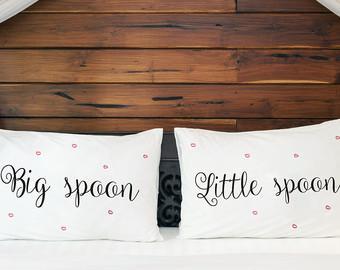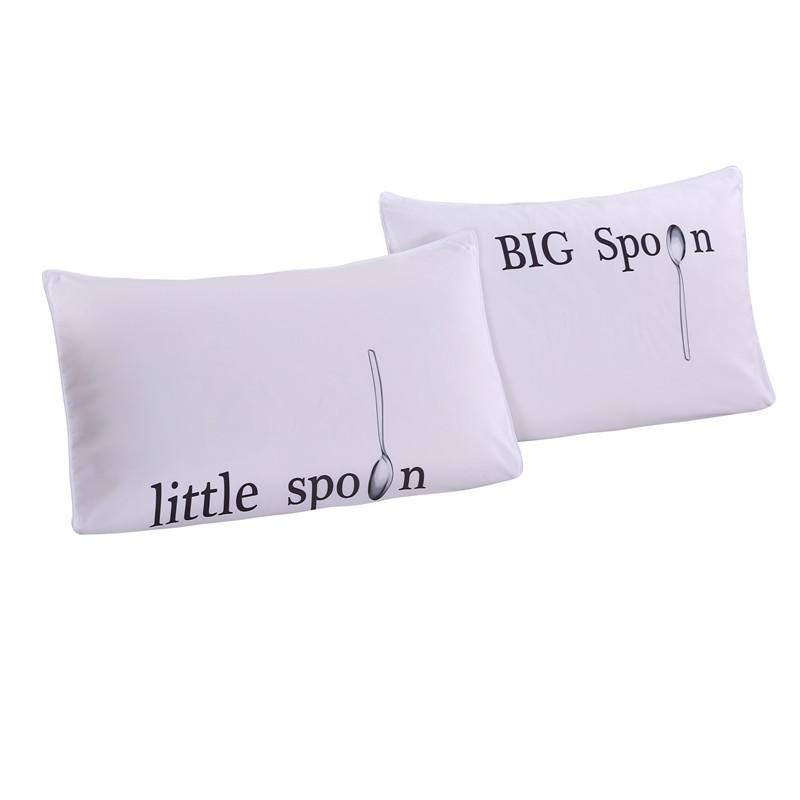The first image is the image on the left, the second image is the image on the right. Examine the images to the left and right. Is the description "One image features a pillow design with a spoon pictured as well as black text, and the other image shows two rectangular white pillows with black text." accurate? Answer yes or no. Yes. The first image is the image on the left, the second image is the image on the right. Evaluate the accuracy of this statement regarding the images: "The right image contains exactly two pillows.". Is it true? Answer yes or no. Yes. 